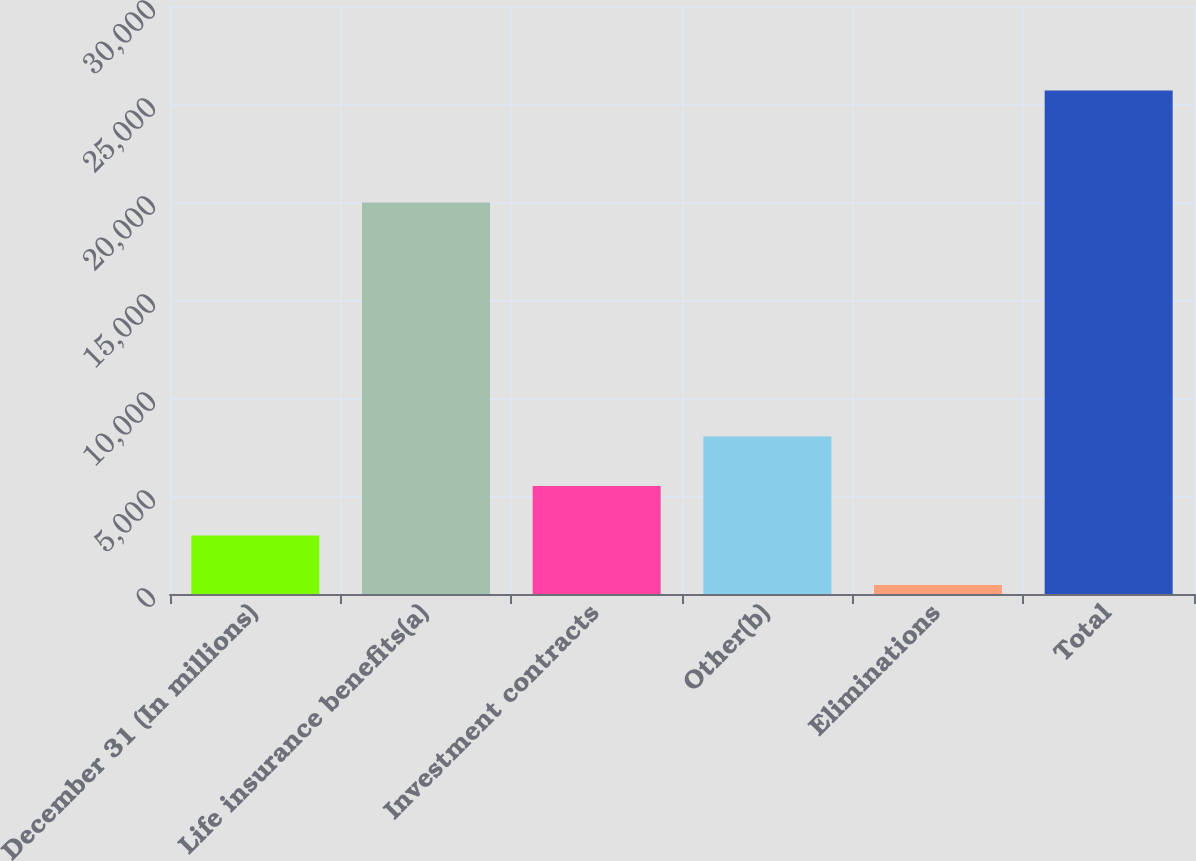Convert chart to OTSL. <chart><loc_0><loc_0><loc_500><loc_500><bar_chart><fcel>December 31 (In millions)<fcel>Life insurance benefits(a)<fcel>Investment contracts<fcel>Other(b)<fcel>Eliminations<fcel>Total<nl><fcel>2985.9<fcel>19978<fcel>5508.8<fcel>8031.7<fcel>463<fcel>25692<nl></chart> 